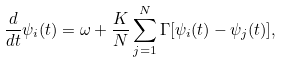<formula> <loc_0><loc_0><loc_500><loc_500>\frac { d } { d t } \psi _ { i } ( t ) = \omega + \frac { K } { N } \sum ^ { N } _ { j = 1 } \Gamma [ \psi _ { i } ( t ) - \psi _ { j } ( t ) ] ,</formula> 